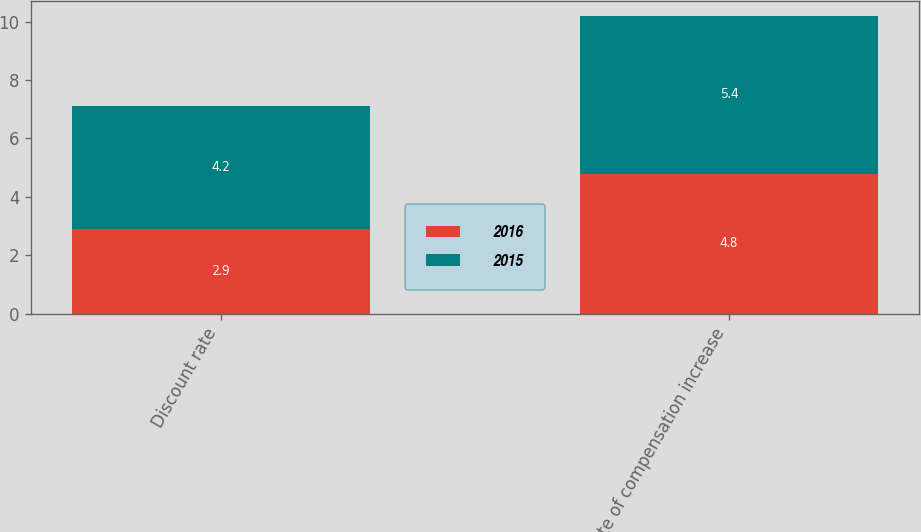<chart> <loc_0><loc_0><loc_500><loc_500><stacked_bar_chart><ecel><fcel>Discount rate<fcel>Rate of compensation increase<nl><fcel>2016<fcel>2.9<fcel>4.8<nl><fcel>2015<fcel>4.2<fcel>5.4<nl></chart> 